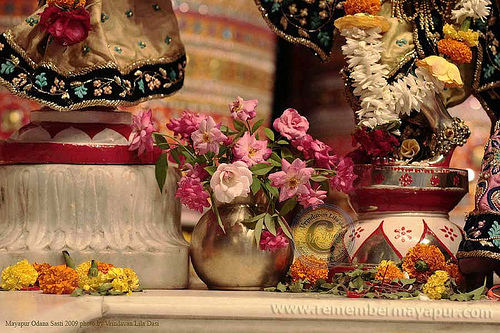Identify and read out the text in this image. www.remembermayapur.com Mayapur Odana Sasti 2009 photo Life 